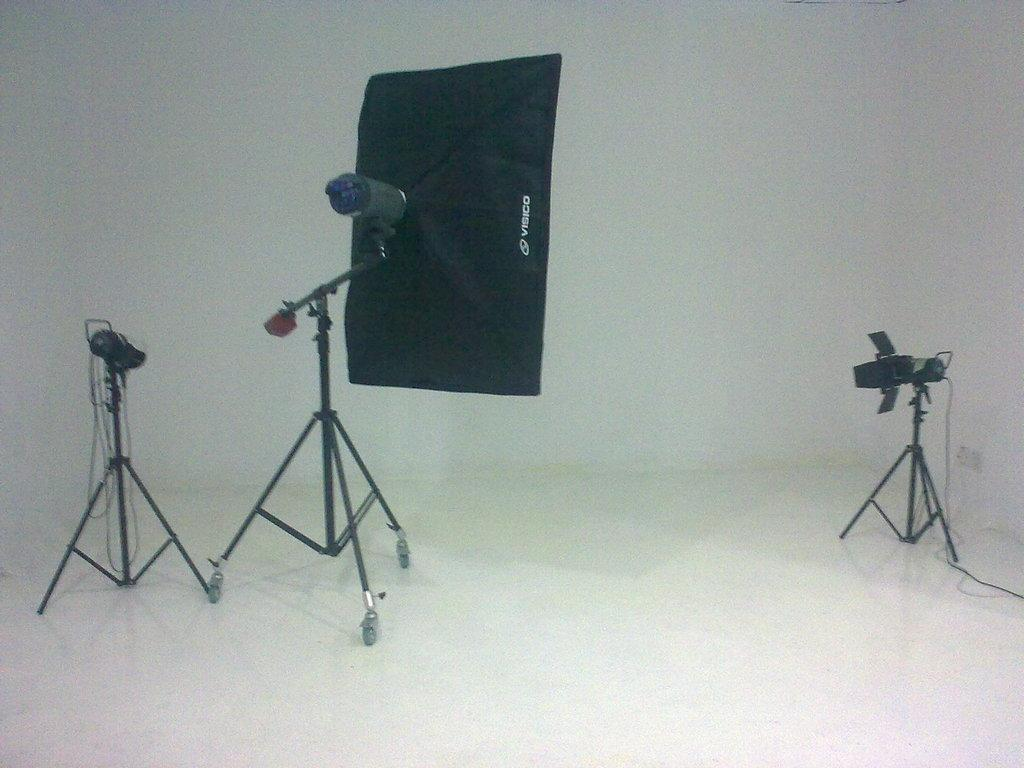What type of equipment is present in the image? There is a softbox and two cameras in the image. What color is the background of the image? The background of the image is white. What type of mailbox can be seen in the image? There is no mailbox present in the image. How does the monkey interact with the softbox in the image? There is no monkey present in the image. 